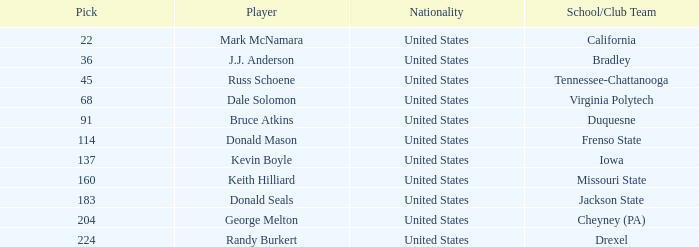What is the nationhood of the drexel participant with a pick exceeding 183? United States. 